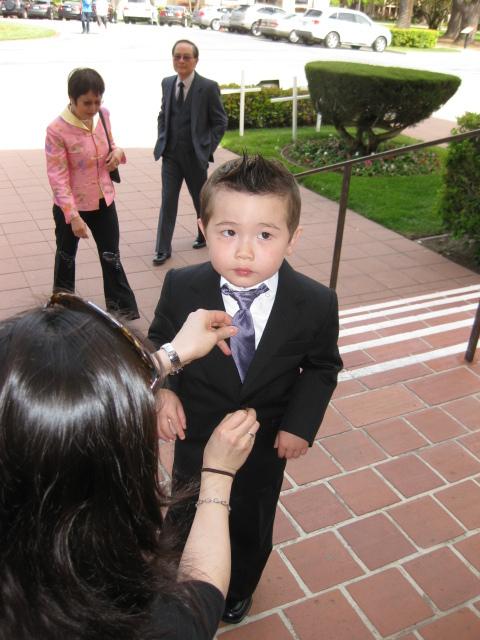Does it seem likely they are going to a rock show?
Concise answer only. No. Is the little boy wearing play clothes?
Short answer required. No. Is this little kid dressed nice?
Quick response, please. Yes. 